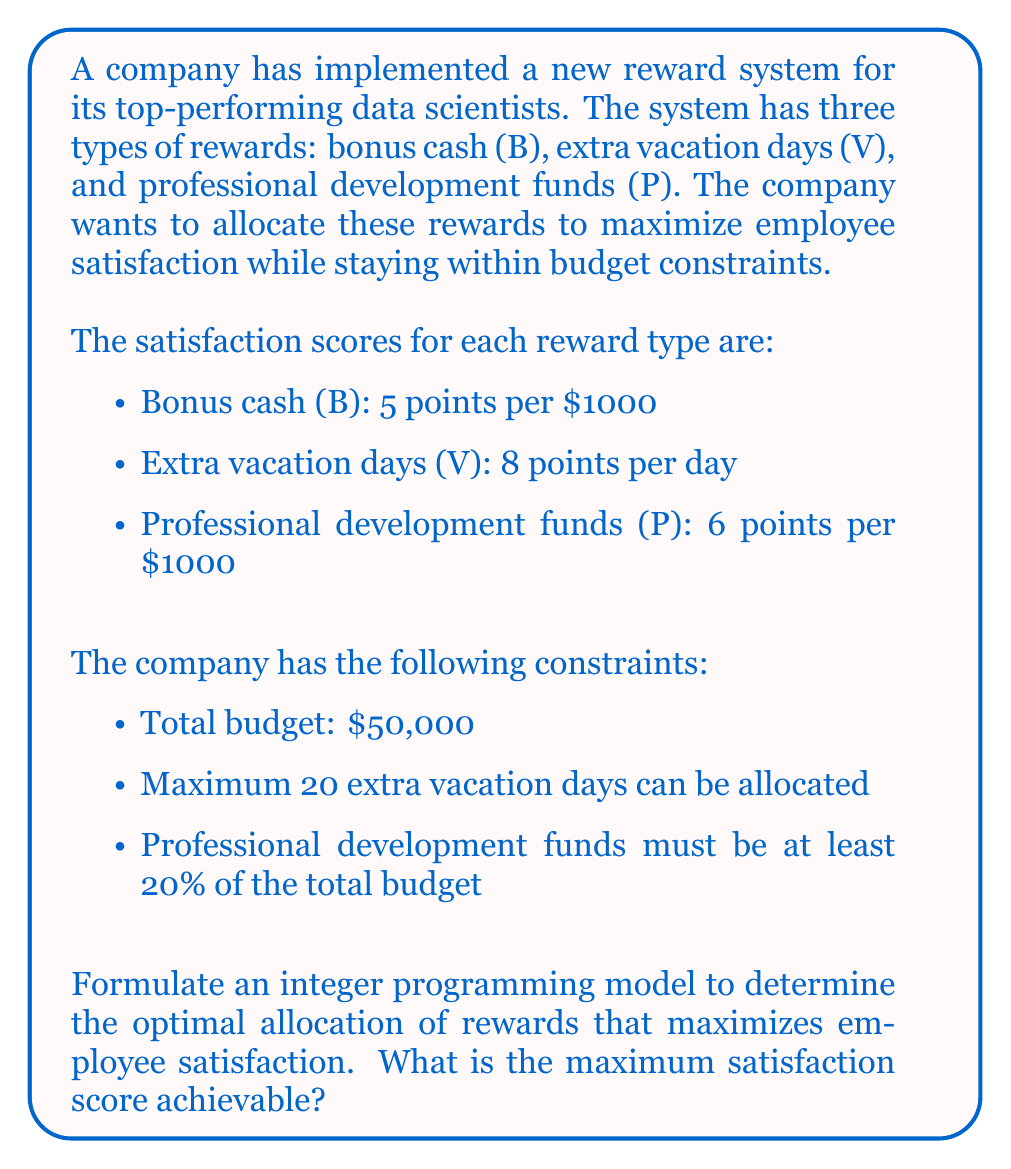Solve this math problem. To solve this problem, we'll use integer programming. Let's define our variables and formulate the model:

Variables:
$B$: Number of $1000 units of bonus cash
$V$: Number of extra vacation days
$P$: Number of $1000 units of professional development funds

Objective function:
Maximize satisfaction: $5B + 8V + 6P$

Constraints:
1. Budget constraint: $B + P \leq 50$ (since B and P are in $1000 units)
2. Vacation days constraint: $V \leq 20$
3. Professional development funds constraint: $P \geq 0.2(B + P)$
4. Integer constraints: $B, V, P$ are non-negative integers

The integer programming model:

$$
\begin{align*}
\text{Maximize} \quad & 5B + 8V + 6P \\
\text{Subject to} \quad & B + P \leq 50 \\
& V \leq 20 \\
& P \geq 0.2(B + P) \\
& B, V, P \in \mathbb{Z}^+ \cup \{0\}
\end{align*}
$$

To solve this, we can use a solver or follow these steps:

1. Simplify the professional development constraint:
   $P \geq 0.2(B + P)$
   $0.8P \geq 0.2B$
   $4P \geq B$

2. The budget constraint will likely be binding, so:
   $B + P = 50$

3. Substituting $B = 50 - P$ into $4P \geq B$:
   $4P \geq 50 - P$
   $5P \geq 50$
   $P \geq 10$

4. Given these constraints, we can try values for P from 10 to 50:

   For $P = 10$:
   $B = 40$, $V = 20$ (maximum allowed)
   Satisfaction = $5(40) + 8(20) + 6(10) = 360$

   For $P = 11$:
   $B = 39$, $V = 20$
   Satisfaction = $5(39) + 8(20) + 6(11) = 361$

   Continuing this process, we find the optimal solution at:
   $P = 12$, $B = 38$, $V = 20$
   Satisfaction = $5(38) + 8(20) + 6(12) = 362$

   Any further increase in P will decrease the overall satisfaction score.
Answer: The optimal allocation is 38 units ($38,000) of bonus cash, 20 extra vacation days, and 12 units ($12,000) of professional development funds. The maximum achievable satisfaction score is 362 points. 